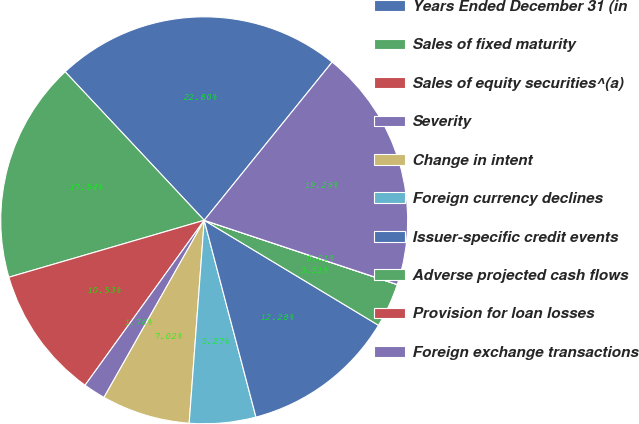Convert chart to OTSL. <chart><loc_0><loc_0><loc_500><loc_500><pie_chart><fcel>Years Ended December 31 (in<fcel>Sales of fixed maturity<fcel>Sales of equity securities^(a)<fcel>Severity<fcel>Change in intent<fcel>Foreign currency declines<fcel>Issuer-specific credit events<fcel>Adverse projected cash flows<fcel>Provision for loan losses<fcel>Foreign exchange transactions<nl><fcel>22.8%<fcel>17.54%<fcel>10.53%<fcel>1.76%<fcel>7.02%<fcel>5.27%<fcel>12.28%<fcel>3.51%<fcel>0.01%<fcel>19.29%<nl></chart> 